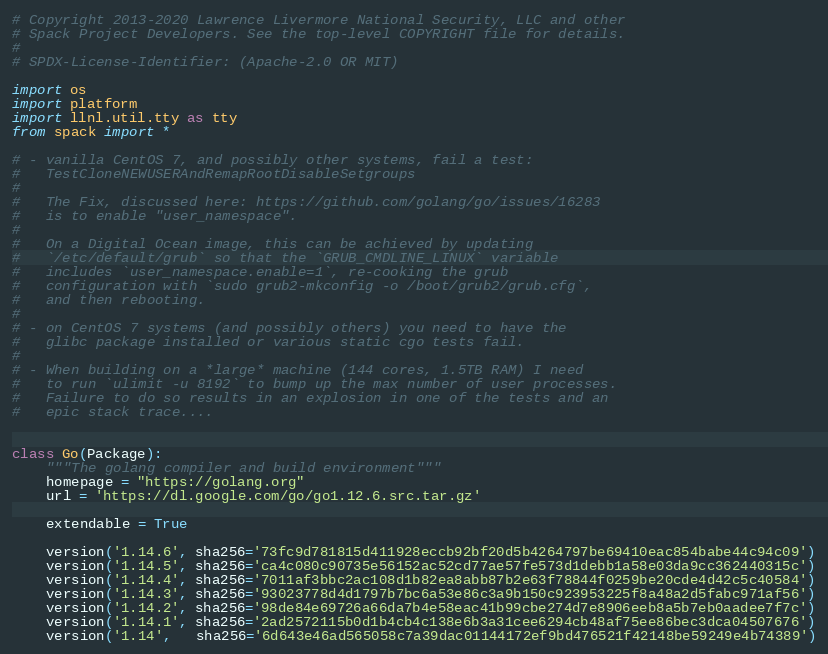<code> <loc_0><loc_0><loc_500><loc_500><_Python_># Copyright 2013-2020 Lawrence Livermore National Security, LLC and other
# Spack Project Developers. See the top-level COPYRIGHT file for details.
#
# SPDX-License-Identifier: (Apache-2.0 OR MIT)

import os
import platform
import llnl.util.tty as tty
from spack import *

# - vanilla CentOS 7, and possibly other systems, fail a test:
#   TestCloneNEWUSERAndRemapRootDisableSetgroups
#
#   The Fix, discussed here: https://github.com/golang/go/issues/16283
#   is to enable "user_namespace".
#
#   On a Digital Ocean image, this can be achieved by updating
#   `/etc/default/grub` so that the `GRUB_CMDLINE_LINUX` variable
#   includes `user_namespace.enable=1`, re-cooking the grub
#   configuration with `sudo grub2-mkconfig -o /boot/grub2/grub.cfg`,
#   and then rebooting.
#
# - on CentOS 7 systems (and possibly others) you need to have the
#   glibc package installed or various static cgo tests fail.
#
# - When building on a *large* machine (144 cores, 1.5TB RAM) I need
#   to run `ulimit -u 8192` to bump up the max number of user processes.
#   Failure to do so results in an explosion in one of the tests and an
#   epic stack trace....


class Go(Package):
    """The golang compiler and build environment"""
    homepage = "https://golang.org"
    url = 'https://dl.google.com/go/go1.12.6.src.tar.gz'

    extendable = True

    version('1.14.6', sha256='73fc9d781815d411928eccb92bf20d5b4264797be69410eac854babe44c94c09')
    version('1.14.5', sha256='ca4c080c90735e56152ac52cd77ae57fe573d1debb1a58e03da9cc362440315c')
    version('1.14.4', sha256='7011af3bbc2ac108d1b82ea8abb87b2e63f78844f0259be20cde4d42c5c40584')
    version('1.14.3', sha256='93023778d4d1797b7bc6a53e86c3a9b150c923953225f8a48a2d5fabc971af56')
    version('1.14.2', sha256='98de84e69726a66da7b4e58eac41b99cbe274d7e8906eeb8a5b7eb0aadee7f7c')
    version('1.14.1', sha256='2ad2572115b0d1b4cb4c138e6b3a31cee6294cb48af75ee86bec3dca04507676')
    version('1.14',   sha256='6d643e46ad565058c7a39dac01144172ef9bd476521f42148be59249e4b74389')</code> 